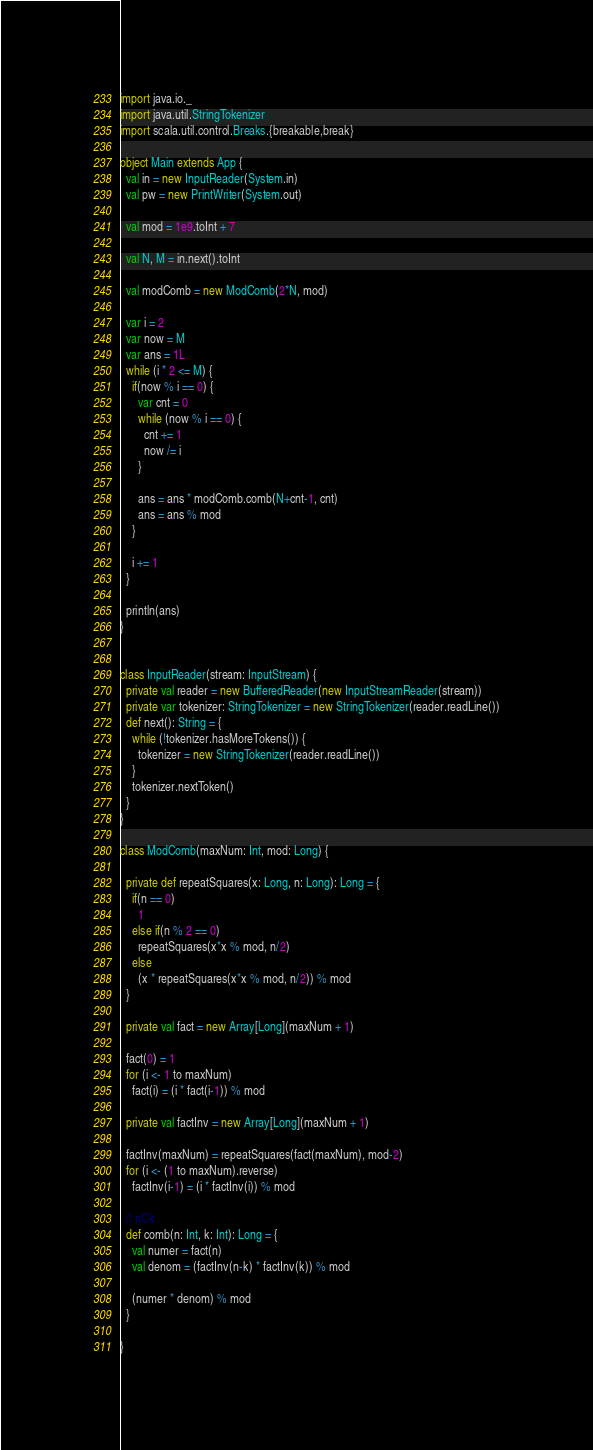Convert code to text. <code><loc_0><loc_0><loc_500><loc_500><_Scala_>import java.io._
import java.util.StringTokenizer
import scala.util.control.Breaks.{breakable,break}

object Main extends App {
  val in = new InputReader(System.in)
  val pw = new PrintWriter(System.out)

  val mod = 1e9.toInt + 7

  val N, M = in.next().toInt

  val modComb = new ModComb(2*N, mod)

  var i = 2
  var now = M
  var ans = 1L
  while (i * 2 <= M) {
    if(now % i == 0) {
      var cnt = 0
      while (now % i == 0) {
        cnt += 1
        now /= i
      }

      ans = ans * modComb.comb(N+cnt-1, cnt)
      ans = ans % mod
    }

    i += 1
  }

  println(ans)
}


class InputReader(stream: InputStream) {
  private val reader = new BufferedReader(new InputStreamReader(stream))
  private var tokenizer: StringTokenizer = new StringTokenizer(reader.readLine())
  def next(): String = {
    while (!tokenizer.hasMoreTokens()) {
      tokenizer = new StringTokenizer(reader.readLine())
    }
    tokenizer.nextToken()
  }
}

class ModComb(maxNum: Int, mod: Long) {

  private def repeatSquares(x: Long, n: Long): Long = {
    if(n == 0)
      1
    else if(n % 2 == 0)
      repeatSquares(x*x % mod, n/2)
    else
      (x * repeatSquares(x*x % mod, n/2)) % mod
  }

  private val fact = new Array[Long](maxNum + 1)

  fact(0) = 1
  for (i <- 1 to maxNum)
    fact(i) = (i * fact(i-1)) % mod

  private val factInv = new Array[Long](maxNum + 1)

  factInv(maxNum) = repeatSquares(fact(maxNum), mod-2)
  for (i <- (1 to maxNum).reverse)
    factInv(i-1) = (i * factInv(i)) % mod

  // nCk
  def comb(n: Int, k: Int): Long = {
    val numer = fact(n)
    val denom = (factInv(n-k) * factInv(k)) % mod

    (numer * denom) % mod
  }

}
</code> 